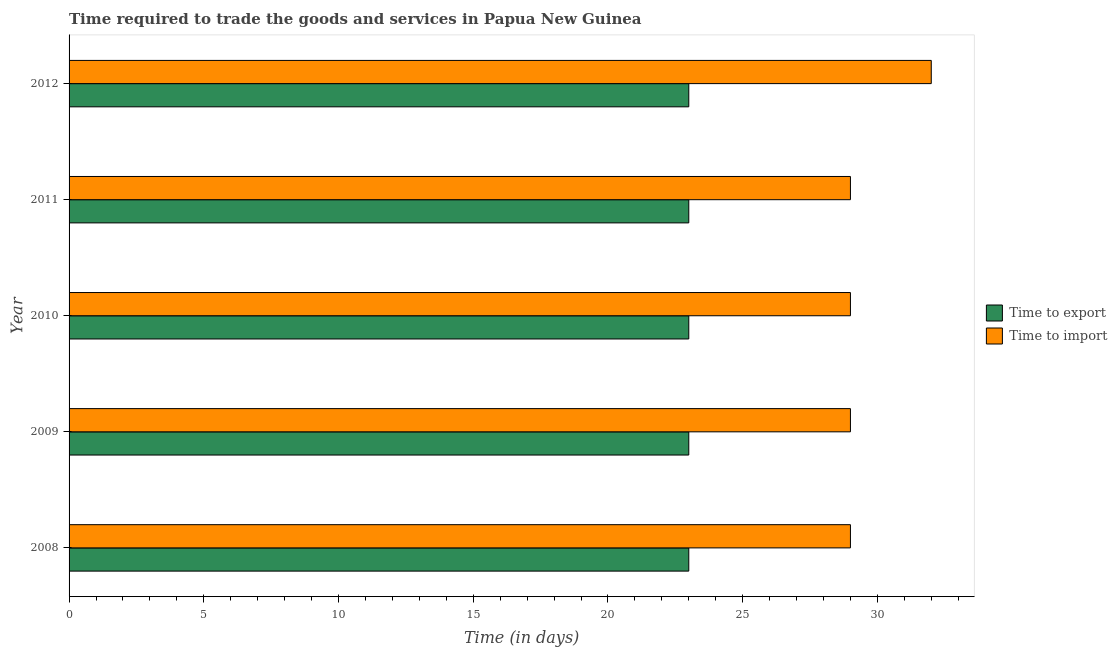How many groups of bars are there?
Keep it short and to the point. 5. How many bars are there on the 2nd tick from the bottom?
Keep it short and to the point. 2. What is the time to export in 2011?
Your answer should be compact. 23. Across all years, what is the maximum time to import?
Your answer should be compact. 32. Across all years, what is the minimum time to import?
Your answer should be very brief. 29. What is the total time to import in the graph?
Give a very brief answer. 148. What is the difference between the time to import in 2009 and that in 2012?
Your response must be concise. -3. What is the average time to import per year?
Make the answer very short. 29.6. In the year 2009, what is the difference between the time to import and time to export?
Give a very brief answer. 6. In how many years, is the time to import greater than 29 days?
Provide a short and direct response. 1. What is the ratio of the time to import in 2008 to that in 2011?
Provide a succinct answer. 1. Is the time to export in 2008 less than that in 2009?
Your response must be concise. No. In how many years, is the time to export greater than the average time to export taken over all years?
Make the answer very short. 0. Is the sum of the time to export in 2009 and 2010 greater than the maximum time to import across all years?
Offer a very short reply. Yes. What does the 1st bar from the top in 2008 represents?
Give a very brief answer. Time to import. What does the 1st bar from the bottom in 2008 represents?
Offer a very short reply. Time to export. How many bars are there?
Offer a terse response. 10. How many years are there in the graph?
Ensure brevity in your answer.  5. Where does the legend appear in the graph?
Offer a very short reply. Center right. How are the legend labels stacked?
Keep it short and to the point. Vertical. What is the title of the graph?
Provide a short and direct response. Time required to trade the goods and services in Papua New Guinea. What is the label or title of the X-axis?
Offer a very short reply. Time (in days). What is the label or title of the Y-axis?
Provide a short and direct response. Year. What is the Time (in days) in Time to export in 2008?
Keep it short and to the point. 23. What is the Time (in days) in Time to import in 2008?
Make the answer very short. 29. What is the Time (in days) of Time to import in 2009?
Your answer should be compact. 29. What is the Time (in days) in Time to import in 2010?
Make the answer very short. 29. What is the Time (in days) in Time to export in 2011?
Provide a short and direct response. 23. What is the Time (in days) of Time to import in 2011?
Make the answer very short. 29. Across all years, what is the minimum Time (in days) of Time to import?
Offer a terse response. 29. What is the total Time (in days) of Time to export in the graph?
Your answer should be compact. 115. What is the total Time (in days) of Time to import in the graph?
Give a very brief answer. 148. What is the difference between the Time (in days) of Time to import in 2008 and that in 2010?
Your response must be concise. 0. What is the difference between the Time (in days) in Time to export in 2008 and that in 2011?
Make the answer very short. 0. What is the difference between the Time (in days) of Time to export in 2009 and that in 2011?
Your answer should be compact. 0. What is the difference between the Time (in days) in Time to export in 2009 and that in 2012?
Make the answer very short. 0. What is the difference between the Time (in days) in Time to import in 2010 and that in 2011?
Make the answer very short. 0. What is the difference between the Time (in days) in Time to export in 2010 and that in 2012?
Ensure brevity in your answer.  0. What is the difference between the Time (in days) of Time to import in 2011 and that in 2012?
Make the answer very short. -3. What is the difference between the Time (in days) of Time to export in 2008 and the Time (in days) of Time to import in 2009?
Ensure brevity in your answer.  -6. What is the difference between the Time (in days) in Time to export in 2009 and the Time (in days) in Time to import in 2011?
Provide a succinct answer. -6. What is the average Time (in days) of Time to export per year?
Ensure brevity in your answer.  23. What is the average Time (in days) of Time to import per year?
Your response must be concise. 29.6. In the year 2009, what is the difference between the Time (in days) of Time to export and Time (in days) of Time to import?
Give a very brief answer. -6. In the year 2010, what is the difference between the Time (in days) of Time to export and Time (in days) of Time to import?
Ensure brevity in your answer.  -6. In the year 2012, what is the difference between the Time (in days) of Time to export and Time (in days) of Time to import?
Offer a terse response. -9. What is the ratio of the Time (in days) in Time to export in 2008 to that in 2009?
Give a very brief answer. 1. What is the ratio of the Time (in days) of Time to export in 2008 to that in 2010?
Offer a very short reply. 1. What is the ratio of the Time (in days) of Time to import in 2008 to that in 2010?
Keep it short and to the point. 1. What is the ratio of the Time (in days) of Time to import in 2008 to that in 2011?
Make the answer very short. 1. What is the ratio of the Time (in days) in Time to import in 2008 to that in 2012?
Offer a very short reply. 0.91. What is the ratio of the Time (in days) in Time to import in 2009 to that in 2010?
Provide a succinct answer. 1. What is the ratio of the Time (in days) in Time to export in 2009 to that in 2012?
Your response must be concise. 1. What is the ratio of the Time (in days) in Time to import in 2009 to that in 2012?
Offer a very short reply. 0.91. What is the ratio of the Time (in days) of Time to import in 2010 to that in 2012?
Your answer should be very brief. 0.91. What is the ratio of the Time (in days) of Time to export in 2011 to that in 2012?
Your answer should be compact. 1. What is the ratio of the Time (in days) of Time to import in 2011 to that in 2012?
Provide a succinct answer. 0.91. What is the difference between the highest and the second highest Time (in days) of Time to export?
Offer a very short reply. 0. What is the difference between the highest and the second highest Time (in days) of Time to import?
Your answer should be compact. 3. What is the difference between the highest and the lowest Time (in days) of Time to import?
Ensure brevity in your answer.  3. 